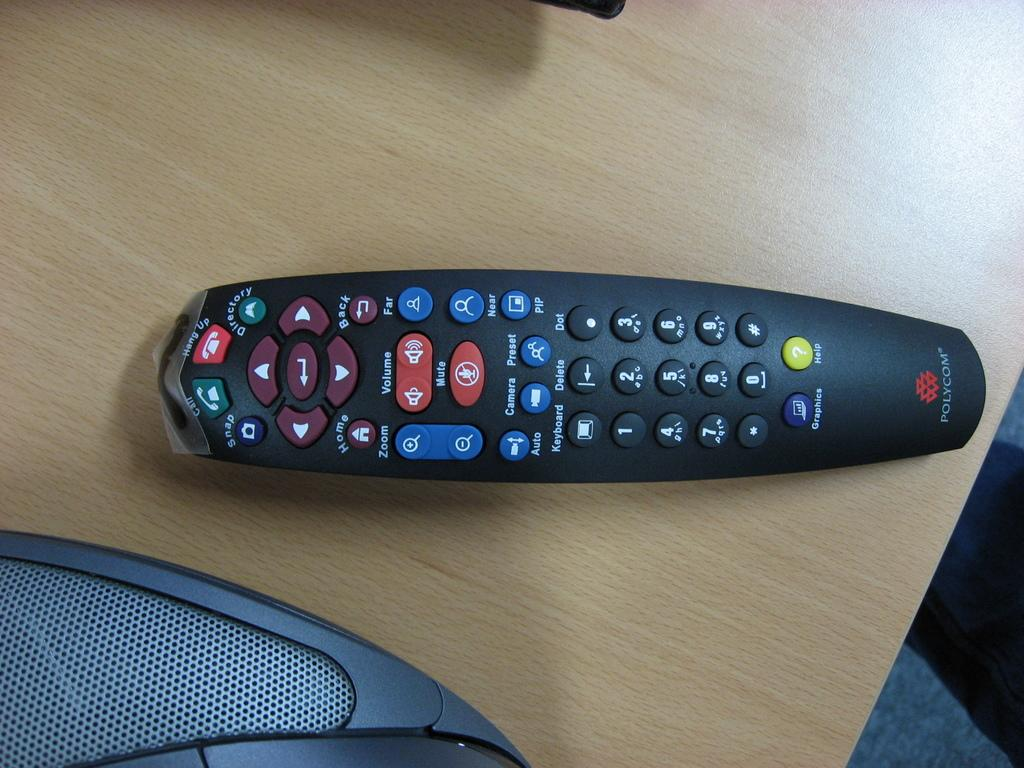<image>
Write a terse but informative summary of the picture. A black Polycom remote control on a wooden table 